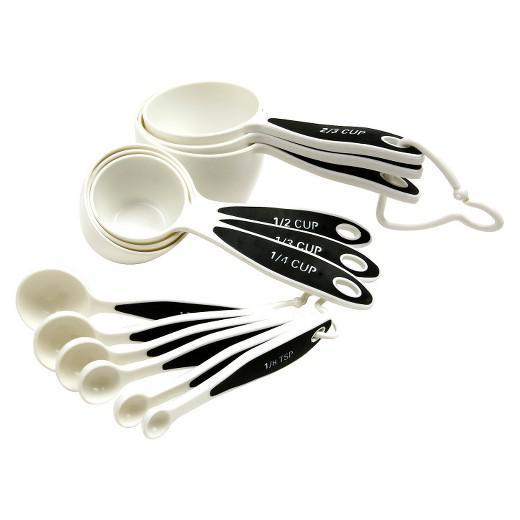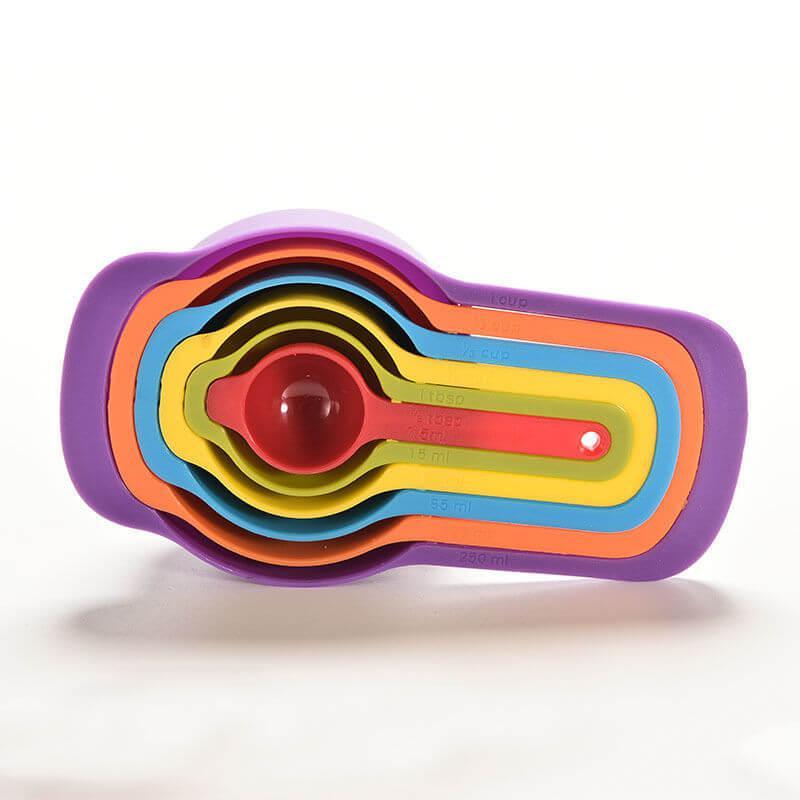The first image is the image on the left, the second image is the image on the right. Evaluate the accuracy of this statement regarding the images: "Measuring spoons and cups appear in at least one image.". Is it true? Answer yes or no. Yes. 